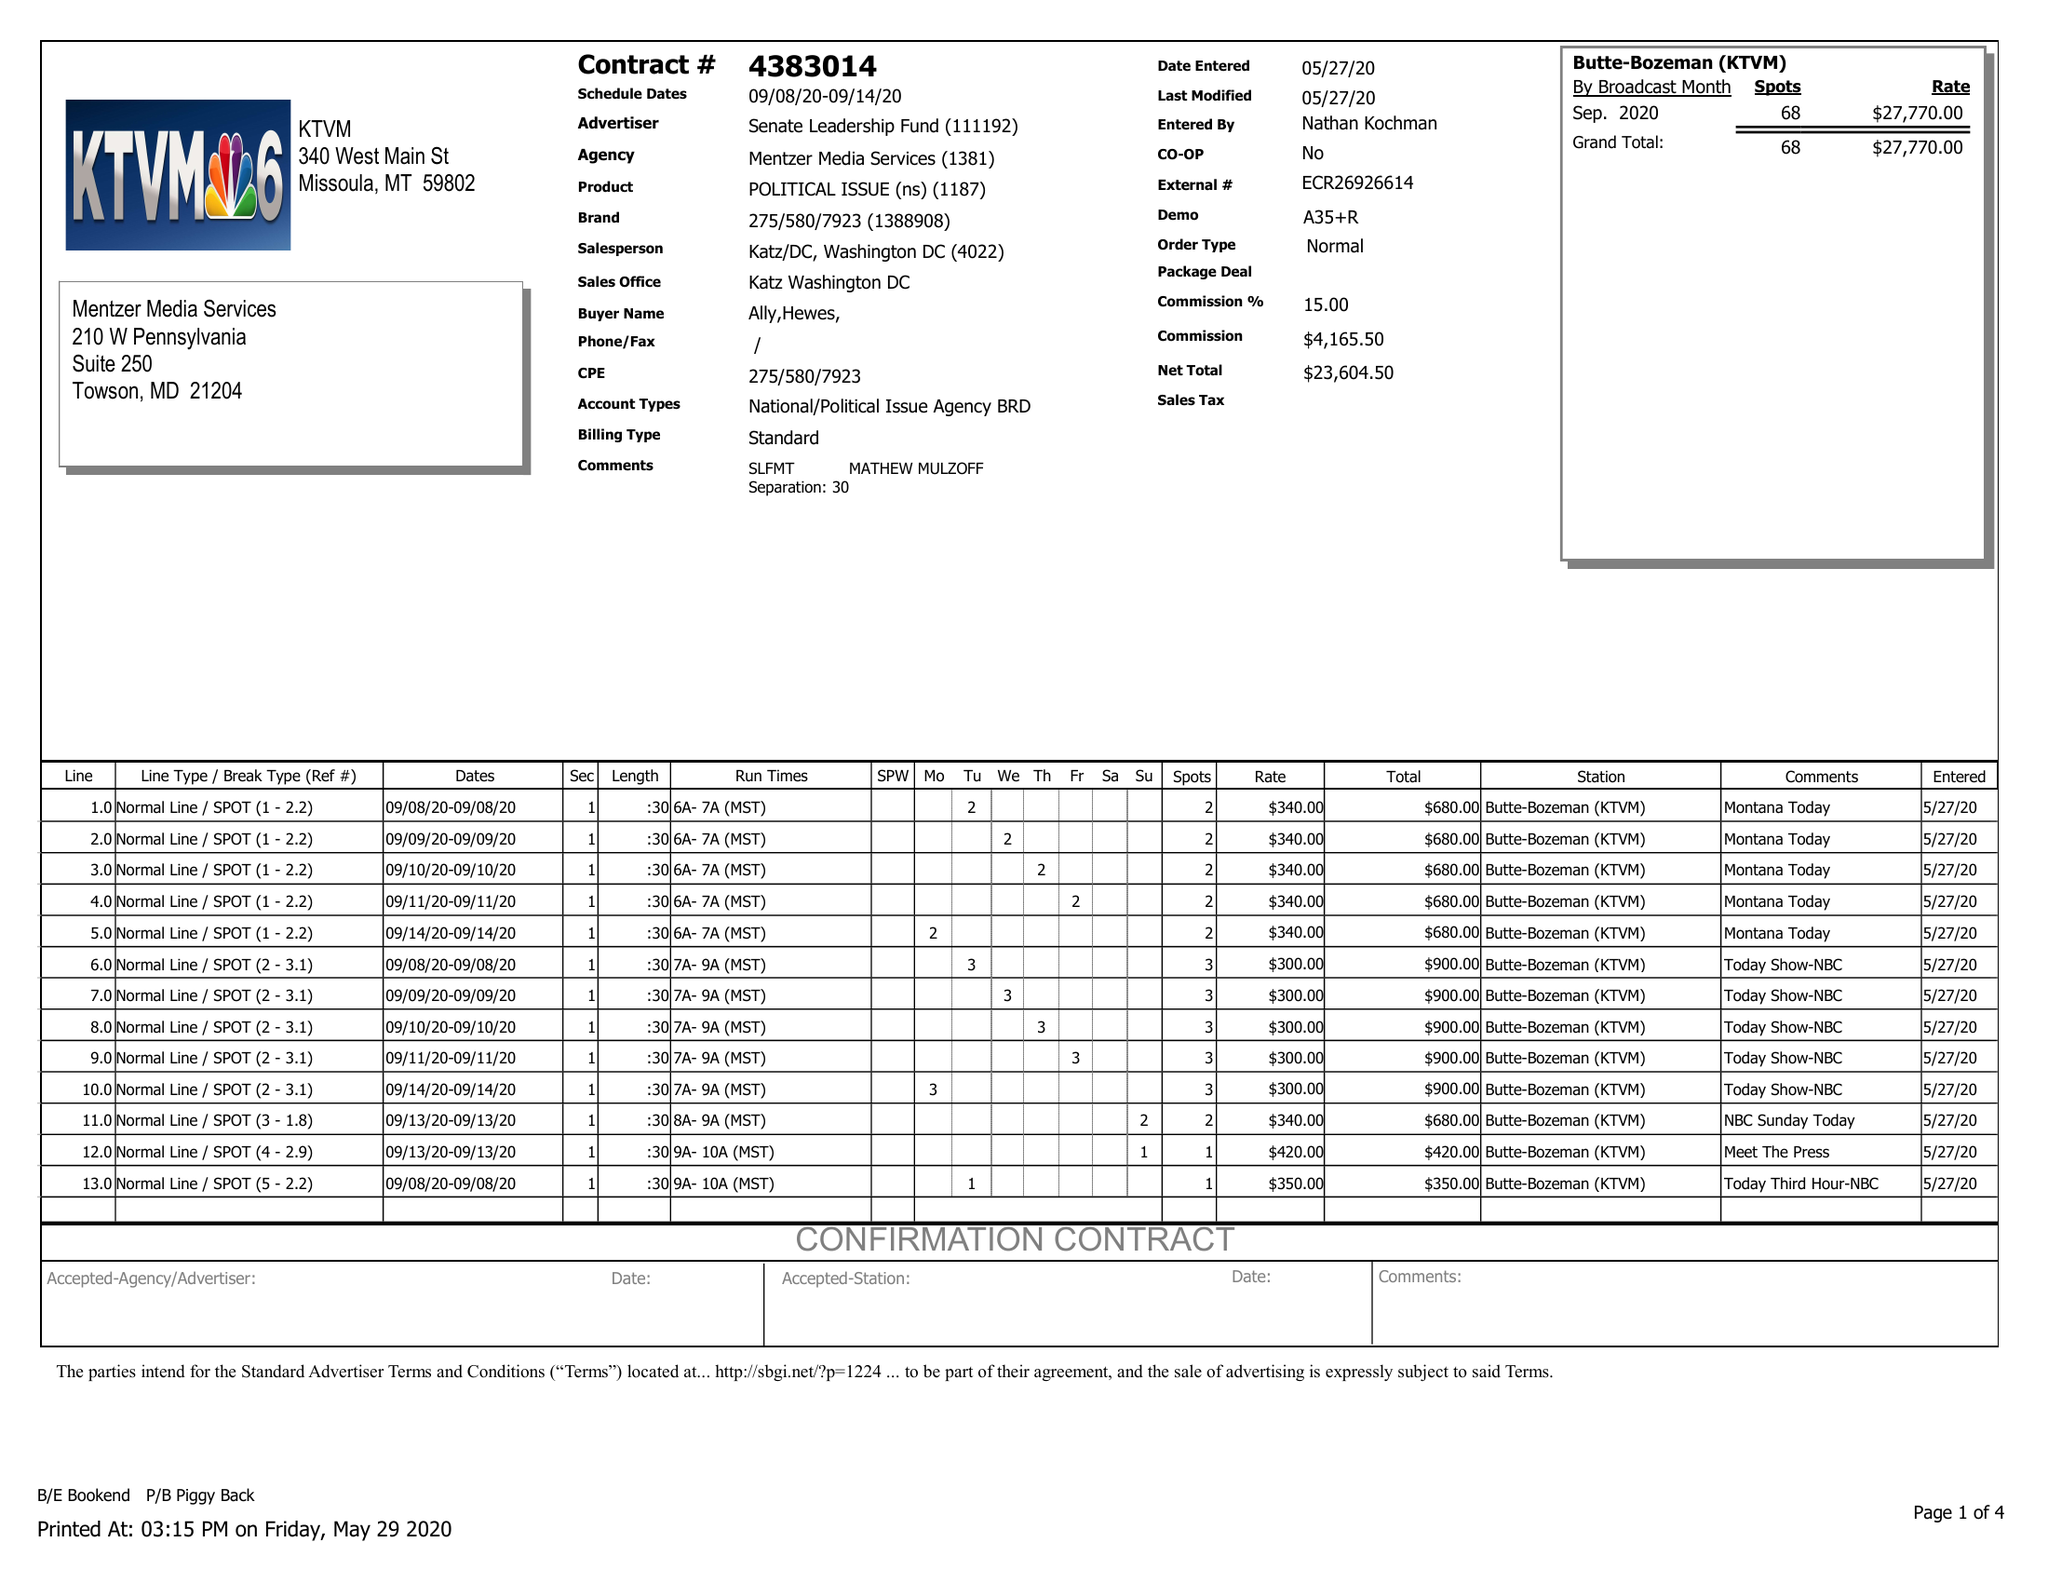What is the value for the flight_from?
Answer the question using a single word or phrase. 09/08/20 